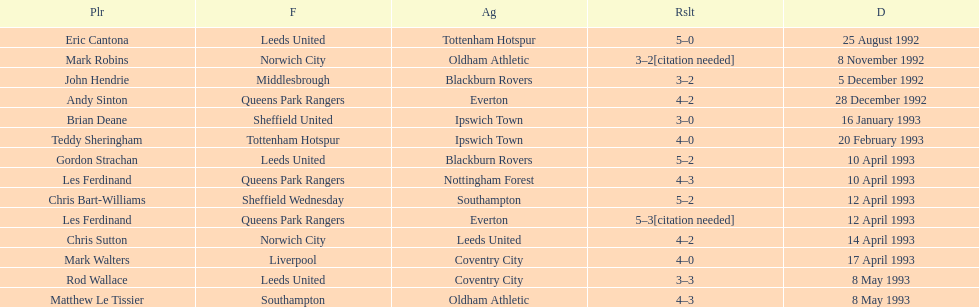Name the only player from france. Eric Cantona. Give me the full table as a dictionary. {'header': ['Plr', 'F', 'Ag', 'Rslt', 'D'], 'rows': [['Eric Cantona', 'Leeds United', 'Tottenham Hotspur', '5–0', '25 August 1992'], ['Mark Robins', 'Norwich City', 'Oldham Athletic', '3–2[citation needed]', '8 November 1992'], ['John Hendrie', 'Middlesbrough', 'Blackburn Rovers', '3–2', '5 December 1992'], ['Andy Sinton', 'Queens Park Rangers', 'Everton', '4–2', '28 December 1992'], ['Brian Deane', 'Sheffield United', 'Ipswich Town', '3–0', '16 January 1993'], ['Teddy Sheringham', 'Tottenham Hotspur', 'Ipswich Town', '4–0', '20 February 1993'], ['Gordon Strachan', 'Leeds United', 'Blackburn Rovers', '5–2', '10 April 1993'], ['Les Ferdinand', 'Queens Park Rangers', 'Nottingham Forest', '4–3', '10 April 1993'], ['Chris Bart-Williams', 'Sheffield Wednesday', 'Southampton', '5–2', '12 April 1993'], ['Les Ferdinand', 'Queens Park Rangers', 'Everton', '5–3[citation needed]', '12 April 1993'], ['Chris Sutton', 'Norwich City', 'Leeds United', '4–2', '14 April 1993'], ['Mark Walters', 'Liverpool', 'Coventry City', '4–0', '17 April 1993'], ['Rod Wallace', 'Leeds United', 'Coventry City', '3–3', '8 May 1993'], ['Matthew Le Tissier', 'Southampton', 'Oldham Athletic', '4–3', '8 May 1993']]} 